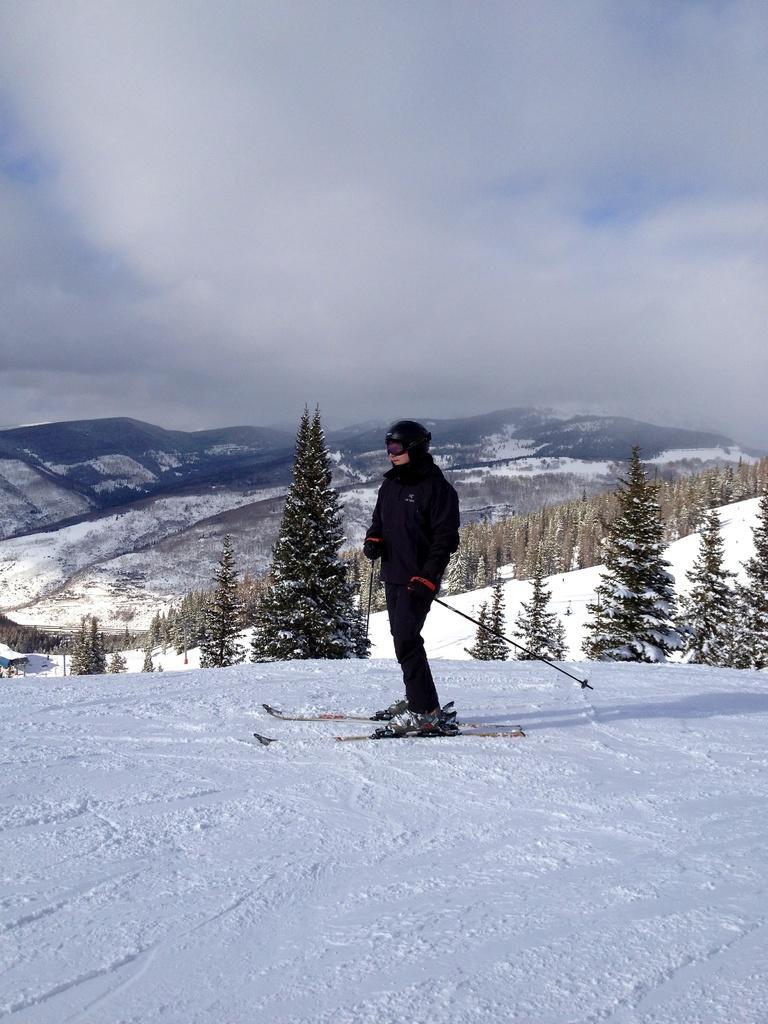In one or two sentences, can you explain what this image depicts? In this image I can see the person is on the ski-boards and holding sticks. I can see few trees, snow, mountains and the sky. 